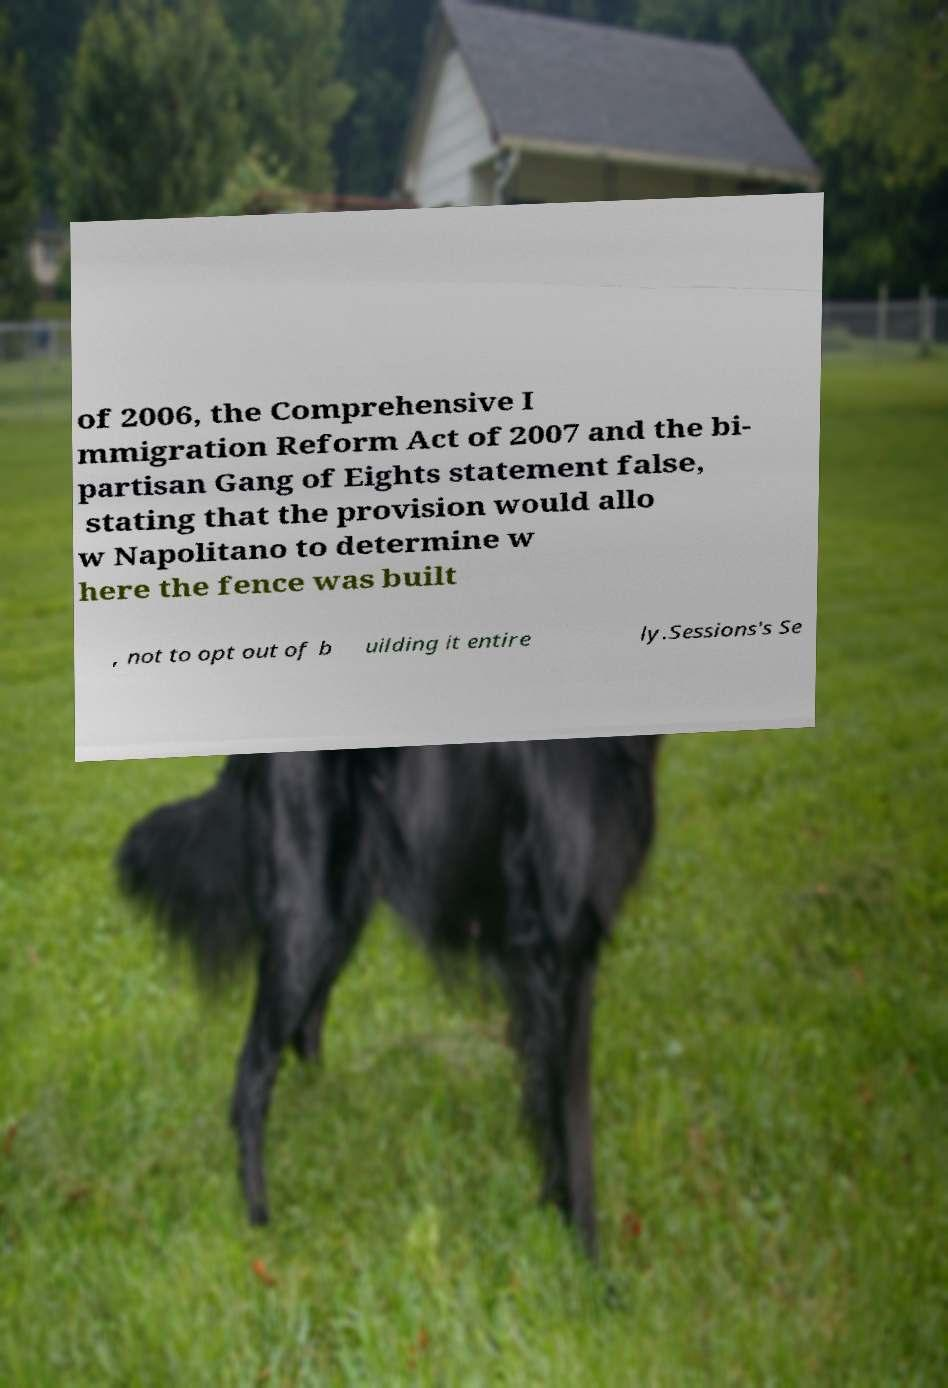Please read and relay the text visible in this image. What does it say? of 2006, the Comprehensive I mmigration Reform Act of 2007 and the bi- partisan Gang of Eights statement false, stating that the provision would allo w Napolitano to determine w here the fence was built , not to opt out of b uilding it entire ly.Sessions's Se 